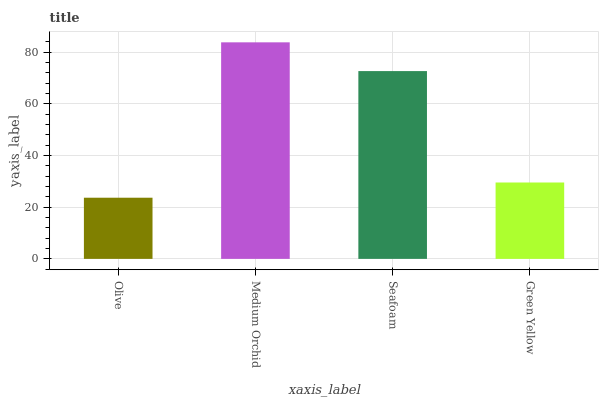Is Olive the minimum?
Answer yes or no. Yes. Is Medium Orchid the maximum?
Answer yes or no. Yes. Is Seafoam the minimum?
Answer yes or no. No. Is Seafoam the maximum?
Answer yes or no. No. Is Medium Orchid greater than Seafoam?
Answer yes or no. Yes. Is Seafoam less than Medium Orchid?
Answer yes or no. Yes. Is Seafoam greater than Medium Orchid?
Answer yes or no. No. Is Medium Orchid less than Seafoam?
Answer yes or no. No. Is Seafoam the high median?
Answer yes or no. Yes. Is Green Yellow the low median?
Answer yes or no. Yes. Is Olive the high median?
Answer yes or no. No. Is Olive the low median?
Answer yes or no. No. 